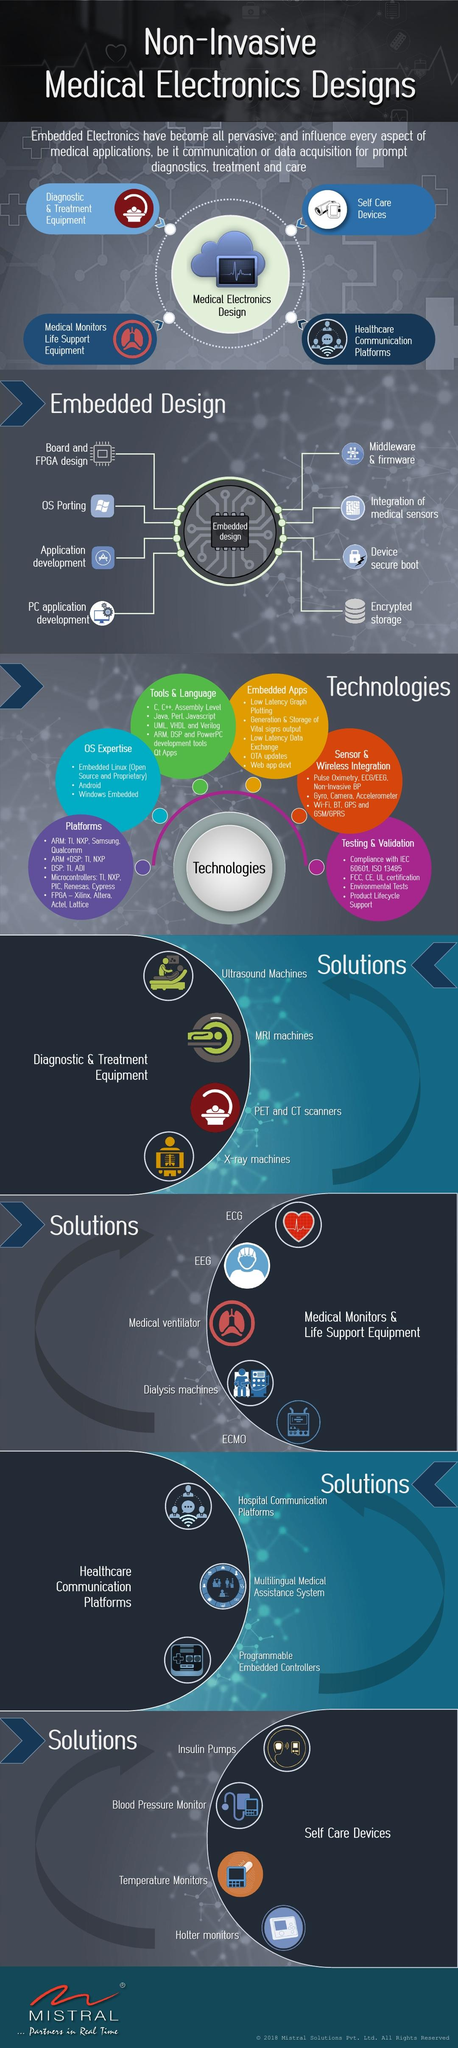Point out several critical features in this image. There are six types of technologies that are commonly applied to embedded design. There are five medical monitors and life support systems listed. C, Python, Java, and C++ are programming languages used in embedded electronics. There are four self-care devices currently listed. 